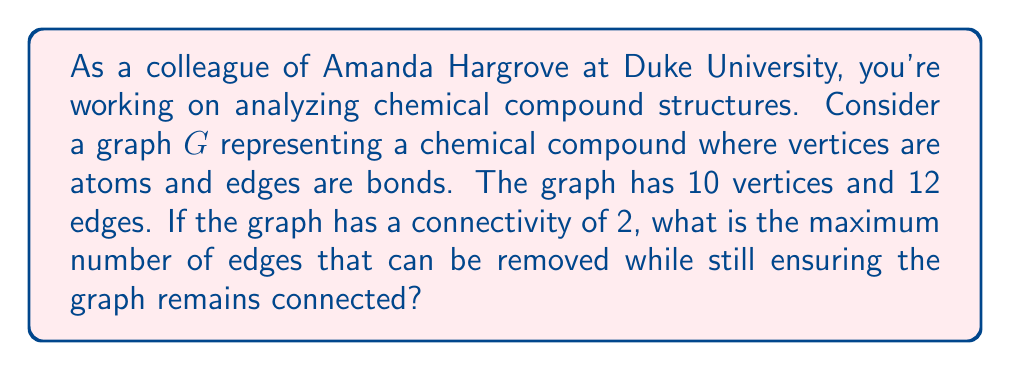Give your solution to this math problem. To solve this problem, we need to understand the concept of graph connectivity and its relation to the number of edges that can be removed while keeping the graph connected.

1. Graph connectivity:
   The connectivity of a graph $G$, denoted as $\kappa(G)$, is the minimum number of vertices that need to be removed to disconnect the graph. In this case, $\kappa(G) = 2$.

2. Relationship between connectivity and edge removal:
   The maximum number of edges that can be removed while keeping the graph connected is equal to $\kappa(G) - 1$. This is because removing $\kappa(G)$ edges could potentially disconnect the graph.

3. Calculating the result:
   Since $\kappa(G) = 2$, the maximum number of edges that can be removed is:
   
   $$\kappa(G) - 1 = 2 - 1 = 1$$

4. Verifying the result:
   - The graph has 10 vertices and 12 edges.
   - Removing 1 edge will leave 11 edges, which is still sufficient to keep all 10 vertices connected.
   - Removing 2 edges could potentially disconnect the graph, as it matches the graph's connectivity.

Therefore, the maximum number of edges that can be removed while ensuring the graph remains connected is 1.
Answer: 1 edge 